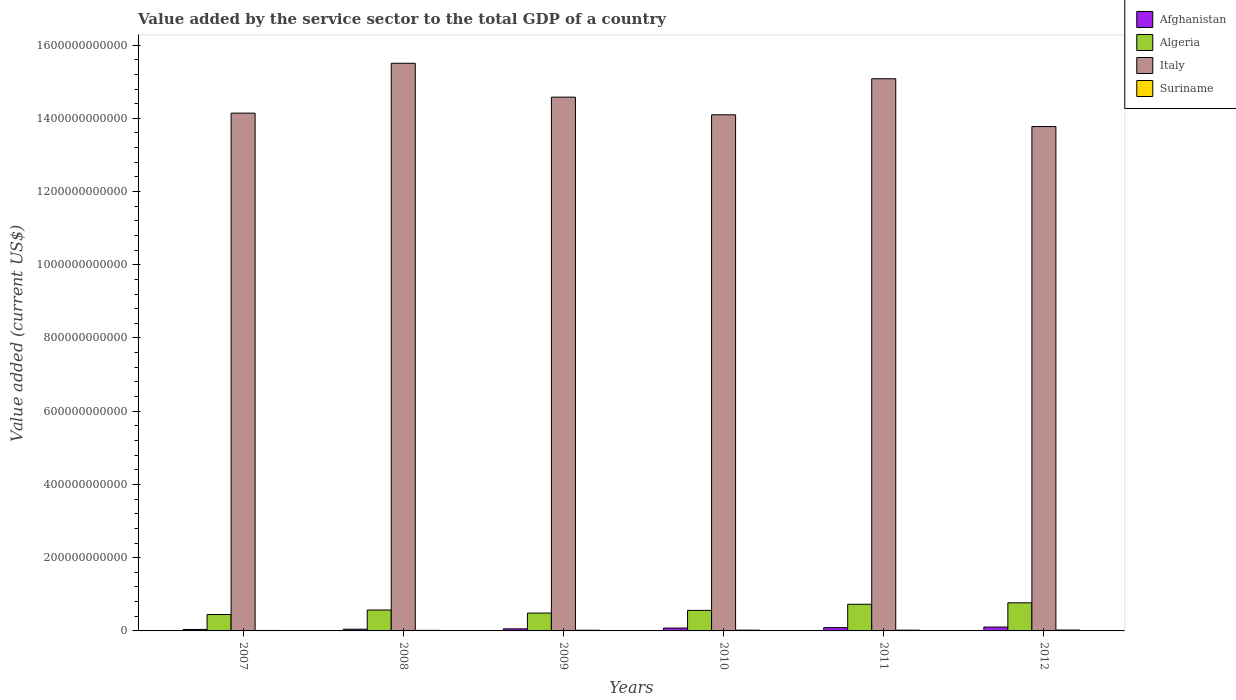How many groups of bars are there?
Your answer should be compact. 6. Are the number of bars per tick equal to the number of legend labels?
Give a very brief answer. Yes. Are the number of bars on each tick of the X-axis equal?
Keep it short and to the point. Yes. How many bars are there on the 1st tick from the left?
Keep it short and to the point. 4. In how many cases, is the number of bars for a given year not equal to the number of legend labels?
Provide a succinct answer. 0. What is the value added by the service sector to the total GDP in Suriname in 2010?
Offer a very short reply. 2.09e+09. Across all years, what is the maximum value added by the service sector to the total GDP in Suriname?
Keep it short and to the point. 2.39e+09. Across all years, what is the minimum value added by the service sector to the total GDP in Afghanistan?
Give a very brief answer. 4.03e+09. In which year was the value added by the service sector to the total GDP in Italy maximum?
Provide a succinct answer. 2008. What is the total value added by the service sector to the total GDP in Algeria in the graph?
Your answer should be compact. 3.56e+11. What is the difference between the value added by the service sector to the total GDP in Suriname in 2009 and that in 2012?
Your answer should be very brief. -5.57e+08. What is the difference between the value added by the service sector to the total GDP in Algeria in 2011 and the value added by the service sector to the total GDP in Italy in 2010?
Offer a very short reply. -1.34e+12. What is the average value added by the service sector to the total GDP in Italy per year?
Provide a short and direct response. 1.45e+12. In the year 2008, what is the difference between the value added by the service sector to the total GDP in Italy and value added by the service sector to the total GDP in Suriname?
Your response must be concise. 1.55e+12. In how many years, is the value added by the service sector to the total GDP in Italy greater than 1400000000000 US$?
Your answer should be very brief. 5. What is the ratio of the value added by the service sector to the total GDP in Algeria in 2008 to that in 2009?
Provide a succinct answer. 1.17. Is the difference between the value added by the service sector to the total GDP in Italy in 2009 and 2010 greater than the difference between the value added by the service sector to the total GDP in Suriname in 2009 and 2010?
Offer a very short reply. Yes. What is the difference between the highest and the second highest value added by the service sector to the total GDP in Suriname?
Give a very brief answer. 3.01e+08. What is the difference between the highest and the lowest value added by the service sector to the total GDP in Italy?
Provide a succinct answer. 1.73e+11. What does the 4th bar from the left in 2009 represents?
Provide a succinct answer. Suriname. What does the 3rd bar from the right in 2007 represents?
Offer a terse response. Algeria. Is it the case that in every year, the sum of the value added by the service sector to the total GDP in Suriname and value added by the service sector to the total GDP in Algeria is greater than the value added by the service sector to the total GDP in Afghanistan?
Provide a short and direct response. Yes. How many bars are there?
Make the answer very short. 24. How many years are there in the graph?
Your answer should be compact. 6. What is the difference between two consecutive major ticks on the Y-axis?
Ensure brevity in your answer.  2.00e+11. Are the values on the major ticks of Y-axis written in scientific E-notation?
Your answer should be compact. No. Does the graph contain any zero values?
Offer a very short reply. No. Does the graph contain grids?
Your answer should be compact. No. How many legend labels are there?
Offer a terse response. 4. How are the legend labels stacked?
Provide a succinct answer. Vertical. What is the title of the graph?
Ensure brevity in your answer.  Value added by the service sector to the total GDP of a country. What is the label or title of the X-axis?
Your answer should be very brief. Years. What is the label or title of the Y-axis?
Offer a terse response. Value added (current US$). What is the Value added (current US$) in Afghanistan in 2007?
Provide a succinct answer. 4.03e+09. What is the Value added (current US$) in Algeria in 2007?
Give a very brief answer. 4.48e+1. What is the Value added (current US$) of Italy in 2007?
Provide a short and direct response. 1.41e+12. What is the Value added (current US$) of Suriname in 2007?
Your response must be concise. 1.30e+09. What is the Value added (current US$) of Afghanistan in 2008?
Ensure brevity in your answer.  4.67e+09. What is the Value added (current US$) of Algeria in 2008?
Your answer should be very brief. 5.71e+1. What is the Value added (current US$) of Italy in 2008?
Give a very brief answer. 1.55e+12. What is the Value added (current US$) of Suriname in 2008?
Provide a short and direct response. 1.55e+09. What is the Value added (current US$) of Afghanistan in 2009?
Give a very brief answer. 5.69e+09. What is the Value added (current US$) in Algeria in 2009?
Your answer should be very brief. 4.88e+1. What is the Value added (current US$) of Italy in 2009?
Provide a short and direct response. 1.46e+12. What is the Value added (current US$) of Suriname in 2009?
Your answer should be compact. 1.83e+09. What is the Value added (current US$) of Afghanistan in 2010?
Make the answer very short. 7.83e+09. What is the Value added (current US$) of Algeria in 2010?
Ensure brevity in your answer.  5.61e+1. What is the Value added (current US$) in Italy in 2010?
Give a very brief answer. 1.41e+12. What is the Value added (current US$) of Suriname in 2010?
Your answer should be very brief. 2.09e+09. What is the Value added (current US$) in Afghanistan in 2011?
Your response must be concise. 8.97e+09. What is the Value added (current US$) of Algeria in 2011?
Give a very brief answer. 7.28e+1. What is the Value added (current US$) in Italy in 2011?
Keep it short and to the point. 1.51e+12. What is the Value added (current US$) of Suriname in 2011?
Provide a succinct answer. 2.06e+09. What is the Value added (current US$) in Afghanistan in 2012?
Provide a succinct answer. 1.06e+1. What is the Value added (current US$) in Algeria in 2012?
Provide a short and direct response. 7.68e+1. What is the Value added (current US$) of Italy in 2012?
Make the answer very short. 1.38e+12. What is the Value added (current US$) of Suriname in 2012?
Give a very brief answer. 2.39e+09. Across all years, what is the maximum Value added (current US$) of Afghanistan?
Keep it short and to the point. 1.06e+1. Across all years, what is the maximum Value added (current US$) of Algeria?
Make the answer very short. 7.68e+1. Across all years, what is the maximum Value added (current US$) in Italy?
Your answer should be compact. 1.55e+12. Across all years, what is the maximum Value added (current US$) of Suriname?
Your answer should be very brief. 2.39e+09. Across all years, what is the minimum Value added (current US$) of Afghanistan?
Offer a terse response. 4.03e+09. Across all years, what is the minimum Value added (current US$) in Algeria?
Provide a short and direct response. 4.48e+1. Across all years, what is the minimum Value added (current US$) in Italy?
Make the answer very short. 1.38e+12. Across all years, what is the minimum Value added (current US$) of Suriname?
Your answer should be compact. 1.30e+09. What is the total Value added (current US$) in Afghanistan in the graph?
Your answer should be compact. 4.18e+1. What is the total Value added (current US$) in Algeria in the graph?
Keep it short and to the point. 3.56e+11. What is the total Value added (current US$) in Italy in the graph?
Keep it short and to the point. 8.72e+12. What is the total Value added (current US$) of Suriname in the graph?
Offer a terse response. 1.12e+1. What is the difference between the Value added (current US$) of Afghanistan in 2007 and that in 2008?
Offer a very short reply. -6.46e+08. What is the difference between the Value added (current US$) in Algeria in 2007 and that in 2008?
Your answer should be compact. -1.22e+1. What is the difference between the Value added (current US$) in Italy in 2007 and that in 2008?
Offer a very short reply. -1.36e+11. What is the difference between the Value added (current US$) of Suriname in 2007 and that in 2008?
Your answer should be compact. -2.44e+08. What is the difference between the Value added (current US$) in Afghanistan in 2007 and that in 2009?
Provide a short and direct response. -1.66e+09. What is the difference between the Value added (current US$) of Algeria in 2007 and that in 2009?
Make the answer very short. -3.97e+09. What is the difference between the Value added (current US$) of Italy in 2007 and that in 2009?
Give a very brief answer. -4.36e+1. What is the difference between the Value added (current US$) of Suriname in 2007 and that in 2009?
Offer a very short reply. -5.31e+08. What is the difference between the Value added (current US$) of Afghanistan in 2007 and that in 2010?
Provide a short and direct response. -3.80e+09. What is the difference between the Value added (current US$) of Algeria in 2007 and that in 2010?
Offer a terse response. -1.13e+1. What is the difference between the Value added (current US$) of Italy in 2007 and that in 2010?
Your answer should be very brief. 4.55e+09. What is the difference between the Value added (current US$) of Suriname in 2007 and that in 2010?
Your answer should be very brief. -7.87e+08. What is the difference between the Value added (current US$) in Afghanistan in 2007 and that in 2011?
Keep it short and to the point. -4.95e+09. What is the difference between the Value added (current US$) in Algeria in 2007 and that in 2011?
Your response must be concise. -2.80e+1. What is the difference between the Value added (current US$) in Italy in 2007 and that in 2011?
Provide a short and direct response. -9.39e+1. What is the difference between the Value added (current US$) of Suriname in 2007 and that in 2011?
Offer a very short reply. -7.61e+08. What is the difference between the Value added (current US$) in Afghanistan in 2007 and that in 2012?
Provide a succinct answer. -6.54e+09. What is the difference between the Value added (current US$) of Algeria in 2007 and that in 2012?
Your answer should be compact. -3.19e+1. What is the difference between the Value added (current US$) in Italy in 2007 and that in 2012?
Offer a terse response. 3.67e+1. What is the difference between the Value added (current US$) of Suriname in 2007 and that in 2012?
Offer a terse response. -1.09e+09. What is the difference between the Value added (current US$) in Afghanistan in 2008 and that in 2009?
Make the answer very short. -1.02e+09. What is the difference between the Value added (current US$) of Algeria in 2008 and that in 2009?
Your answer should be compact. 8.27e+09. What is the difference between the Value added (current US$) in Italy in 2008 and that in 2009?
Provide a succinct answer. 9.26e+1. What is the difference between the Value added (current US$) in Suriname in 2008 and that in 2009?
Keep it short and to the point. -2.87e+08. What is the difference between the Value added (current US$) of Afghanistan in 2008 and that in 2010?
Provide a short and direct response. -3.16e+09. What is the difference between the Value added (current US$) of Algeria in 2008 and that in 2010?
Ensure brevity in your answer.  9.84e+08. What is the difference between the Value added (current US$) of Italy in 2008 and that in 2010?
Keep it short and to the point. 1.41e+11. What is the difference between the Value added (current US$) in Suriname in 2008 and that in 2010?
Provide a succinct answer. -5.43e+08. What is the difference between the Value added (current US$) of Afghanistan in 2008 and that in 2011?
Offer a very short reply. -4.30e+09. What is the difference between the Value added (current US$) of Algeria in 2008 and that in 2011?
Offer a terse response. -1.57e+1. What is the difference between the Value added (current US$) in Italy in 2008 and that in 2011?
Offer a terse response. 4.23e+1. What is the difference between the Value added (current US$) in Suriname in 2008 and that in 2011?
Keep it short and to the point. -5.17e+08. What is the difference between the Value added (current US$) of Afghanistan in 2008 and that in 2012?
Make the answer very short. -5.90e+09. What is the difference between the Value added (current US$) in Algeria in 2008 and that in 2012?
Provide a short and direct response. -1.97e+1. What is the difference between the Value added (current US$) of Italy in 2008 and that in 2012?
Ensure brevity in your answer.  1.73e+11. What is the difference between the Value added (current US$) in Suriname in 2008 and that in 2012?
Your answer should be very brief. -8.44e+08. What is the difference between the Value added (current US$) in Afghanistan in 2009 and that in 2010?
Give a very brief answer. -2.14e+09. What is the difference between the Value added (current US$) of Algeria in 2009 and that in 2010?
Your answer should be compact. -7.29e+09. What is the difference between the Value added (current US$) of Italy in 2009 and that in 2010?
Provide a succinct answer. 4.82e+1. What is the difference between the Value added (current US$) in Suriname in 2009 and that in 2010?
Provide a succinct answer. -2.56e+08. What is the difference between the Value added (current US$) in Afghanistan in 2009 and that in 2011?
Give a very brief answer. -3.29e+09. What is the difference between the Value added (current US$) of Algeria in 2009 and that in 2011?
Ensure brevity in your answer.  -2.40e+1. What is the difference between the Value added (current US$) in Italy in 2009 and that in 2011?
Give a very brief answer. -5.03e+1. What is the difference between the Value added (current US$) in Suriname in 2009 and that in 2011?
Offer a terse response. -2.30e+08. What is the difference between the Value added (current US$) in Afghanistan in 2009 and that in 2012?
Keep it short and to the point. -4.88e+09. What is the difference between the Value added (current US$) of Algeria in 2009 and that in 2012?
Ensure brevity in your answer.  -2.80e+1. What is the difference between the Value added (current US$) of Italy in 2009 and that in 2012?
Offer a terse response. 8.03e+1. What is the difference between the Value added (current US$) of Suriname in 2009 and that in 2012?
Offer a terse response. -5.57e+08. What is the difference between the Value added (current US$) of Afghanistan in 2010 and that in 2011?
Ensure brevity in your answer.  -1.14e+09. What is the difference between the Value added (current US$) of Algeria in 2010 and that in 2011?
Your answer should be very brief. -1.67e+1. What is the difference between the Value added (current US$) of Italy in 2010 and that in 2011?
Your response must be concise. -9.85e+1. What is the difference between the Value added (current US$) in Suriname in 2010 and that in 2011?
Make the answer very short. 2.58e+07. What is the difference between the Value added (current US$) in Afghanistan in 2010 and that in 2012?
Your answer should be compact. -2.74e+09. What is the difference between the Value added (current US$) of Algeria in 2010 and that in 2012?
Keep it short and to the point. -2.07e+1. What is the difference between the Value added (current US$) in Italy in 2010 and that in 2012?
Ensure brevity in your answer.  3.21e+1. What is the difference between the Value added (current US$) of Suriname in 2010 and that in 2012?
Your answer should be compact. -3.01e+08. What is the difference between the Value added (current US$) of Afghanistan in 2011 and that in 2012?
Your answer should be compact. -1.59e+09. What is the difference between the Value added (current US$) of Algeria in 2011 and that in 2012?
Give a very brief answer. -3.96e+09. What is the difference between the Value added (current US$) in Italy in 2011 and that in 2012?
Give a very brief answer. 1.31e+11. What is the difference between the Value added (current US$) of Suriname in 2011 and that in 2012?
Give a very brief answer. -3.27e+08. What is the difference between the Value added (current US$) in Afghanistan in 2007 and the Value added (current US$) in Algeria in 2008?
Your answer should be compact. -5.31e+1. What is the difference between the Value added (current US$) in Afghanistan in 2007 and the Value added (current US$) in Italy in 2008?
Make the answer very short. -1.55e+12. What is the difference between the Value added (current US$) of Afghanistan in 2007 and the Value added (current US$) of Suriname in 2008?
Your answer should be very brief. 2.48e+09. What is the difference between the Value added (current US$) of Algeria in 2007 and the Value added (current US$) of Italy in 2008?
Your answer should be compact. -1.51e+12. What is the difference between the Value added (current US$) in Algeria in 2007 and the Value added (current US$) in Suriname in 2008?
Your response must be concise. 4.33e+1. What is the difference between the Value added (current US$) of Italy in 2007 and the Value added (current US$) of Suriname in 2008?
Ensure brevity in your answer.  1.41e+12. What is the difference between the Value added (current US$) in Afghanistan in 2007 and the Value added (current US$) in Algeria in 2009?
Make the answer very short. -4.48e+1. What is the difference between the Value added (current US$) of Afghanistan in 2007 and the Value added (current US$) of Italy in 2009?
Keep it short and to the point. -1.45e+12. What is the difference between the Value added (current US$) of Afghanistan in 2007 and the Value added (current US$) of Suriname in 2009?
Ensure brevity in your answer.  2.19e+09. What is the difference between the Value added (current US$) of Algeria in 2007 and the Value added (current US$) of Italy in 2009?
Your answer should be very brief. -1.41e+12. What is the difference between the Value added (current US$) of Algeria in 2007 and the Value added (current US$) of Suriname in 2009?
Your answer should be compact. 4.30e+1. What is the difference between the Value added (current US$) in Italy in 2007 and the Value added (current US$) in Suriname in 2009?
Ensure brevity in your answer.  1.41e+12. What is the difference between the Value added (current US$) in Afghanistan in 2007 and the Value added (current US$) in Algeria in 2010?
Offer a terse response. -5.21e+1. What is the difference between the Value added (current US$) of Afghanistan in 2007 and the Value added (current US$) of Italy in 2010?
Keep it short and to the point. -1.41e+12. What is the difference between the Value added (current US$) of Afghanistan in 2007 and the Value added (current US$) of Suriname in 2010?
Offer a very short reply. 1.94e+09. What is the difference between the Value added (current US$) in Algeria in 2007 and the Value added (current US$) in Italy in 2010?
Provide a short and direct response. -1.36e+12. What is the difference between the Value added (current US$) of Algeria in 2007 and the Value added (current US$) of Suriname in 2010?
Provide a succinct answer. 4.28e+1. What is the difference between the Value added (current US$) in Italy in 2007 and the Value added (current US$) in Suriname in 2010?
Your answer should be compact. 1.41e+12. What is the difference between the Value added (current US$) of Afghanistan in 2007 and the Value added (current US$) of Algeria in 2011?
Provide a short and direct response. -6.88e+1. What is the difference between the Value added (current US$) in Afghanistan in 2007 and the Value added (current US$) in Italy in 2011?
Your answer should be very brief. -1.50e+12. What is the difference between the Value added (current US$) in Afghanistan in 2007 and the Value added (current US$) in Suriname in 2011?
Your answer should be compact. 1.96e+09. What is the difference between the Value added (current US$) in Algeria in 2007 and the Value added (current US$) in Italy in 2011?
Ensure brevity in your answer.  -1.46e+12. What is the difference between the Value added (current US$) of Algeria in 2007 and the Value added (current US$) of Suriname in 2011?
Offer a very short reply. 4.28e+1. What is the difference between the Value added (current US$) in Italy in 2007 and the Value added (current US$) in Suriname in 2011?
Provide a succinct answer. 1.41e+12. What is the difference between the Value added (current US$) in Afghanistan in 2007 and the Value added (current US$) in Algeria in 2012?
Offer a very short reply. -7.28e+1. What is the difference between the Value added (current US$) in Afghanistan in 2007 and the Value added (current US$) in Italy in 2012?
Provide a succinct answer. -1.37e+12. What is the difference between the Value added (current US$) of Afghanistan in 2007 and the Value added (current US$) of Suriname in 2012?
Offer a terse response. 1.64e+09. What is the difference between the Value added (current US$) in Algeria in 2007 and the Value added (current US$) in Italy in 2012?
Give a very brief answer. -1.33e+12. What is the difference between the Value added (current US$) in Algeria in 2007 and the Value added (current US$) in Suriname in 2012?
Your answer should be compact. 4.25e+1. What is the difference between the Value added (current US$) of Italy in 2007 and the Value added (current US$) of Suriname in 2012?
Ensure brevity in your answer.  1.41e+12. What is the difference between the Value added (current US$) of Afghanistan in 2008 and the Value added (current US$) of Algeria in 2009?
Your response must be concise. -4.41e+1. What is the difference between the Value added (current US$) in Afghanistan in 2008 and the Value added (current US$) in Italy in 2009?
Offer a very short reply. -1.45e+12. What is the difference between the Value added (current US$) of Afghanistan in 2008 and the Value added (current US$) of Suriname in 2009?
Keep it short and to the point. 2.84e+09. What is the difference between the Value added (current US$) of Algeria in 2008 and the Value added (current US$) of Italy in 2009?
Provide a succinct answer. -1.40e+12. What is the difference between the Value added (current US$) of Algeria in 2008 and the Value added (current US$) of Suriname in 2009?
Your answer should be very brief. 5.53e+1. What is the difference between the Value added (current US$) in Italy in 2008 and the Value added (current US$) in Suriname in 2009?
Your answer should be very brief. 1.55e+12. What is the difference between the Value added (current US$) in Afghanistan in 2008 and the Value added (current US$) in Algeria in 2010?
Ensure brevity in your answer.  -5.14e+1. What is the difference between the Value added (current US$) in Afghanistan in 2008 and the Value added (current US$) in Italy in 2010?
Offer a very short reply. -1.40e+12. What is the difference between the Value added (current US$) of Afghanistan in 2008 and the Value added (current US$) of Suriname in 2010?
Provide a short and direct response. 2.58e+09. What is the difference between the Value added (current US$) of Algeria in 2008 and the Value added (current US$) of Italy in 2010?
Offer a very short reply. -1.35e+12. What is the difference between the Value added (current US$) of Algeria in 2008 and the Value added (current US$) of Suriname in 2010?
Your answer should be very brief. 5.50e+1. What is the difference between the Value added (current US$) of Italy in 2008 and the Value added (current US$) of Suriname in 2010?
Your answer should be compact. 1.55e+12. What is the difference between the Value added (current US$) in Afghanistan in 2008 and the Value added (current US$) in Algeria in 2011?
Provide a succinct answer. -6.81e+1. What is the difference between the Value added (current US$) in Afghanistan in 2008 and the Value added (current US$) in Italy in 2011?
Make the answer very short. -1.50e+12. What is the difference between the Value added (current US$) in Afghanistan in 2008 and the Value added (current US$) in Suriname in 2011?
Provide a succinct answer. 2.61e+09. What is the difference between the Value added (current US$) in Algeria in 2008 and the Value added (current US$) in Italy in 2011?
Make the answer very short. -1.45e+12. What is the difference between the Value added (current US$) of Algeria in 2008 and the Value added (current US$) of Suriname in 2011?
Provide a succinct answer. 5.50e+1. What is the difference between the Value added (current US$) in Italy in 2008 and the Value added (current US$) in Suriname in 2011?
Make the answer very short. 1.55e+12. What is the difference between the Value added (current US$) of Afghanistan in 2008 and the Value added (current US$) of Algeria in 2012?
Your answer should be compact. -7.21e+1. What is the difference between the Value added (current US$) of Afghanistan in 2008 and the Value added (current US$) of Italy in 2012?
Keep it short and to the point. -1.37e+12. What is the difference between the Value added (current US$) of Afghanistan in 2008 and the Value added (current US$) of Suriname in 2012?
Your answer should be compact. 2.28e+09. What is the difference between the Value added (current US$) of Algeria in 2008 and the Value added (current US$) of Italy in 2012?
Your response must be concise. -1.32e+12. What is the difference between the Value added (current US$) in Algeria in 2008 and the Value added (current US$) in Suriname in 2012?
Make the answer very short. 5.47e+1. What is the difference between the Value added (current US$) in Italy in 2008 and the Value added (current US$) in Suriname in 2012?
Your answer should be very brief. 1.55e+12. What is the difference between the Value added (current US$) of Afghanistan in 2009 and the Value added (current US$) of Algeria in 2010?
Provide a succinct answer. -5.04e+1. What is the difference between the Value added (current US$) of Afghanistan in 2009 and the Value added (current US$) of Italy in 2010?
Keep it short and to the point. -1.40e+12. What is the difference between the Value added (current US$) in Afghanistan in 2009 and the Value added (current US$) in Suriname in 2010?
Provide a succinct answer. 3.60e+09. What is the difference between the Value added (current US$) in Algeria in 2009 and the Value added (current US$) in Italy in 2010?
Keep it short and to the point. -1.36e+12. What is the difference between the Value added (current US$) in Algeria in 2009 and the Value added (current US$) in Suriname in 2010?
Offer a terse response. 4.67e+1. What is the difference between the Value added (current US$) in Italy in 2009 and the Value added (current US$) in Suriname in 2010?
Offer a terse response. 1.46e+12. What is the difference between the Value added (current US$) in Afghanistan in 2009 and the Value added (current US$) in Algeria in 2011?
Give a very brief answer. -6.71e+1. What is the difference between the Value added (current US$) of Afghanistan in 2009 and the Value added (current US$) of Italy in 2011?
Keep it short and to the point. -1.50e+12. What is the difference between the Value added (current US$) in Afghanistan in 2009 and the Value added (current US$) in Suriname in 2011?
Make the answer very short. 3.62e+09. What is the difference between the Value added (current US$) in Algeria in 2009 and the Value added (current US$) in Italy in 2011?
Offer a terse response. -1.46e+12. What is the difference between the Value added (current US$) of Algeria in 2009 and the Value added (current US$) of Suriname in 2011?
Your answer should be very brief. 4.68e+1. What is the difference between the Value added (current US$) in Italy in 2009 and the Value added (current US$) in Suriname in 2011?
Ensure brevity in your answer.  1.46e+12. What is the difference between the Value added (current US$) of Afghanistan in 2009 and the Value added (current US$) of Algeria in 2012?
Give a very brief answer. -7.11e+1. What is the difference between the Value added (current US$) of Afghanistan in 2009 and the Value added (current US$) of Italy in 2012?
Keep it short and to the point. -1.37e+12. What is the difference between the Value added (current US$) of Afghanistan in 2009 and the Value added (current US$) of Suriname in 2012?
Your answer should be compact. 3.30e+09. What is the difference between the Value added (current US$) of Algeria in 2009 and the Value added (current US$) of Italy in 2012?
Ensure brevity in your answer.  -1.33e+12. What is the difference between the Value added (current US$) of Algeria in 2009 and the Value added (current US$) of Suriname in 2012?
Offer a terse response. 4.64e+1. What is the difference between the Value added (current US$) of Italy in 2009 and the Value added (current US$) of Suriname in 2012?
Offer a terse response. 1.46e+12. What is the difference between the Value added (current US$) of Afghanistan in 2010 and the Value added (current US$) of Algeria in 2011?
Ensure brevity in your answer.  -6.50e+1. What is the difference between the Value added (current US$) in Afghanistan in 2010 and the Value added (current US$) in Italy in 2011?
Give a very brief answer. -1.50e+12. What is the difference between the Value added (current US$) in Afghanistan in 2010 and the Value added (current US$) in Suriname in 2011?
Provide a succinct answer. 5.77e+09. What is the difference between the Value added (current US$) of Algeria in 2010 and the Value added (current US$) of Italy in 2011?
Give a very brief answer. -1.45e+12. What is the difference between the Value added (current US$) in Algeria in 2010 and the Value added (current US$) in Suriname in 2011?
Your response must be concise. 5.40e+1. What is the difference between the Value added (current US$) in Italy in 2010 and the Value added (current US$) in Suriname in 2011?
Your answer should be compact. 1.41e+12. What is the difference between the Value added (current US$) of Afghanistan in 2010 and the Value added (current US$) of Algeria in 2012?
Your answer should be very brief. -6.90e+1. What is the difference between the Value added (current US$) in Afghanistan in 2010 and the Value added (current US$) in Italy in 2012?
Keep it short and to the point. -1.37e+12. What is the difference between the Value added (current US$) in Afghanistan in 2010 and the Value added (current US$) in Suriname in 2012?
Your answer should be compact. 5.44e+09. What is the difference between the Value added (current US$) in Algeria in 2010 and the Value added (current US$) in Italy in 2012?
Provide a succinct answer. -1.32e+12. What is the difference between the Value added (current US$) of Algeria in 2010 and the Value added (current US$) of Suriname in 2012?
Your response must be concise. 5.37e+1. What is the difference between the Value added (current US$) of Italy in 2010 and the Value added (current US$) of Suriname in 2012?
Make the answer very short. 1.41e+12. What is the difference between the Value added (current US$) of Afghanistan in 2011 and the Value added (current US$) of Algeria in 2012?
Your answer should be compact. -6.78e+1. What is the difference between the Value added (current US$) in Afghanistan in 2011 and the Value added (current US$) in Italy in 2012?
Provide a succinct answer. -1.37e+12. What is the difference between the Value added (current US$) in Afghanistan in 2011 and the Value added (current US$) in Suriname in 2012?
Offer a terse response. 6.58e+09. What is the difference between the Value added (current US$) in Algeria in 2011 and the Value added (current US$) in Italy in 2012?
Ensure brevity in your answer.  -1.30e+12. What is the difference between the Value added (current US$) of Algeria in 2011 and the Value added (current US$) of Suriname in 2012?
Ensure brevity in your answer.  7.04e+1. What is the difference between the Value added (current US$) of Italy in 2011 and the Value added (current US$) of Suriname in 2012?
Keep it short and to the point. 1.51e+12. What is the average Value added (current US$) of Afghanistan per year?
Provide a succinct answer. 6.96e+09. What is the average Value added (current US$) of Algeria per year?
Your response must be concise. 5.94e+1. What is the average Value added (current US$) in Italy per year?
Your answer should be very brief. 1.45e+12. What is the average Value added (current US$) of Suriname per year?
Offer a terse response. 1.87e+09. In the year 2007, what is the difference between the Value added (current US$) in Afghanistan and Value added (current US$) in Algeria?
Make the answer very short. -4.08e+1. In the year 2007, what is the difference between the Value added (current US$) of Afghanistan and Value added (current US$) of Italy?
Provide a succinct answer. -1.41e+12. In the year 2007, what is the difference between the Value added (current US$) of Afghanistan and Value added (current US$) of Suriname?
Provide a succinct answer. 2.72e+09. In the year 2007, what is the difference between the Value added (current US$) in Algeria and Value added (current US$) in Italy?
Your response must be concise. -1.37e+12. In the year 2007, what is the difference between the Value added (current US$) in Algeria and Value added (current US$) in Suriname?
Your response must be concise. 4.35e+1. In the year 2007, what is the difference between the Value added (current US$) in Italy and Value added (current US$) in Suriname?
Give a very brief answer. 1.41e+12. In the year 2008, what is the difference between the Value added (current US$) in Afghanistan and Value added (current US$) in Algeria?
Your answer should be compact. -5.24e+1. In the year 2008, what is the difference between the Value added (current US$) of Afghanistan and Value added (current US$) of Italy?
Ensure brevity in your answer.  -1.55e+12. In the year 2008, what is the difference between the Value added (current US$) in Afghanistan and Value added (current US$) in Suriname?
Give a very brief answer. 3.12e+09. In the year 2008, what is the difference between the Value added (current US$) in Algeria and Value added (current US$) in Italy?
Your answer should be compact. -1.49e+12. In the year 2008, what is the difference between the Value added (current US$) of Algeria and Value added (current US$) of Suriname?
Offer a terse response. 5.55e+1. In the year 2008, what is the difference between the Value added (current US$) in Italy and Value added (current US$) in Suriname?
Your response must be concise. 1.55e+12. In the year 2009, what is the difference between the Value added (current US$) of Afghanistan and Value added (current US$) of Algeria?
Your answer should be compact. -4.31e+1. In the year 2009, what is the difference between the Value added (current US$) of Afghanistan and Value added (current US$) of Italy?
Provide a succinct answer. -1.45e+12. In the year 2009, what is the difference between the Value added (current US$) in Afghanistan and Value added (current US$) in Suriname?
Offer a terse response. 3.85e+09. In the year 2009, what is the difference between the Value added (current US$) in Algeria and Value added (current US$) in Italy?
Your answer should be compact. -1.41e+12. In the year 2009, what is the difference between the Value added (current US$) in Algeria and Value added (current US$) in Suriname?
Give a very brief answer. 4.70e+1. In the year 2009, what is the difference between the Value added (current US$) of Italy and Value added (current US$) of Suriname?
Keep it short and to the point. 1.46e+12. In the year 2010, what is the difference between the Value added (current US$) in Afghanistan and Value added (current US$) in Algeria?
Your answer should be very brief. -4.83e+1. In the year 2010, what is the difference between the Value added (current US$) in Afghanistan and Value added (current US$) in Italy?
Offer a terse response. -1.40e+12. In the year 2010, what is the difference between the Value added (current US$) in Afghanistan and Value added (current US$) in Suriname?
Offer a very short reply. 5.74e+09. In the year 2010, what is the difference between the Value added (current US$) in Algeria and Value added (current US$) in Italy?
Ensure brevity in your answer.  -1.35e+12. In the year 2010, what is the difference between the Value added (current US$) of Algeria and Value added (current US$) of Suriname?
Make the answer very short. 5.40e+1. In the year 2010, what is the difference between the Value added (current US$) in Italy and Value added (current US$) in Suriname?
Offer a terse response. 1.41e+12. In the year 2011, what is the difference between the Value added (current US$) in Afghanistan and Value added (current US$) in Algeria?
Give a very brief answer. -6.38e+1. In the year 2011, what is the difference between the Value added (current US$) of Afghanistan and Value added (current US$) of Italy?
Your answer should be compact. -1.50e+12. In the year 2011, what is the difference between the Value added (current US$) of Afghanistan and Value added (current US$) of Suriname?
Give a very brief answer. 6.91e+09. In the year 2011, what is the difference between the Value added (current US$) of Algeria and Value added (current US$) of Italy?
Offer a terse response. -1.44e+12. In the year 2011, what is the difference between the Value added (current US$) in Algeria and Value added (current US$) in Suriname?
Give a very brief answer. 7.08e+1. In the year 2011, what is the difference between the Value added (current US$) of Italy and Value added (current US$) of Suriname?
Provide a short and direct response. 1.51e+12. In the year 2012, what is the difference between the Value added (current US$) of Afghanistan and Value added (current US$) of Algeria?
Provide a short and direct response. -6.62e+1. In the year 2012, what is the difference between the Value added (current US$) of Afghanistan and Value added (current US$) of Italy?
Provide a short and direct response. -1.37e+12. In the year 2012, what is the difference between the Value added (current US$) of Afghanistan and Value added (current US$) of Suriname?
Your response must be concise. 8.18e+09. In the year 2012, what is the difference between the Value added (current US$) of Algeria and Value added (current US$) of Italy?
Give a very brief answer. -1.30e+12. In the year 2012, what is the difference between the Value added (current US$) of Algeria and Value added (current US$) of Suriname?
Provide a succinct answer. 7.44e+1. In the year 2012, what is the difference between the Value added (current US$) of Italy and Value added (current US$) of Suriname?
Give a very brief answer. 1.38e+12. What is the ratio of the Value added (current US$) of Afghanistan in 2007 to that in 2008?
Your answer should be very brief. 0.86. What is the ratio of the Value added (current US$) in Algeria in 2007 to that in 2008?
Your answer should be compact. 0.79. What is the ratio of the Value added (current US$) of Italy in 2007 to that in 2008?
Keep it short and to the point. 0.91. What is the ratio of the Value added (current US$) in Suriname in 2007 to that in 2008?
Keep it short and to the point. 0.84. What is the ratio of the Value added (current US$) of Afghanistan in 2007 to that in 2009?
Keep it short and to the point. 0.71. What is the ratio of the Value added (current US$) in Algeria in 2007 to that in 2009?
Give a very brief answer. 0.92. What is the ratio of the Value added (current US$) of Italy in 2007 to that in 2009?
Make the answer very short. 0.97. What is the ratio of the Value added (current US$) in Suriname in 2007 to that in 2009?
Offer a very short reply. 0.71. What is the ratio of the Value added (current US$) in Afghanistan in 2007 to that in 2010?
Provide a short and direct response. 0.51. What is the ratio of the Value added (current US$) in Algeria in 2007 to that in 2010?
Give a very brief answer. 0.8. What is the ratio of the Value added (current US$) in Suriname in 2007 to that in 2010?
Your answer should be compact. 0.62. What is the ratio of the Value added (current US$) of Afghanistan in 2007 to that in 2011?
Your answer should be compact. 0.45. What is the ratio of the Value added (current US$) of Algeria in 2007 to that in 2011?
Ensure brevity in your answer.  0.62. What is the ratio of the Value added (current US$) in Italy in 2007 to that in 2011?
Your response must be concise. 0.94. What is the ratio of the Value added (current US$) of Suriname in 2007 to that in 2011?
Your response must be concise. 0.63. What is the ratio of the Value added (current US$) of Afghanistan in 2007 to that in 2012?
Offer a very short reply. 0.38. What is the ratio of the Value added (current US$) of Algeria in 2007 to that in 2012?
Offer a very short reply. 0.58. What is the ratio of the Value added (current US$) of Italy in 2007 to that in 2012?
Offer a terse response. 1.03. What is the ratio of the Value added (current US$) of Suriname in 2007 to that in 2012?
Provide a succinct answer. 0.55. What is the ratio of the Value added (current US$) of Afghanistan in 2008 to that in 2009?
Make the answer very short. 0.82. What is the ratio of the Value added (current US$) of Algeria in 2008 to that in 2009?
Provide a short and direct response. 1.17. What is the ratio of the Value added (current US$) in Italy in 2008 to that in 2009?
Ensure brevity in your answer.  1.06. What is the ratio of the Value added (current US$) in Suriname in 2008 to that in 2009?
Provide a short and direct response. 0.84. What is the ratio of the Value added (current US$) in Afghanistan in 2008 to that in 2010?
Provide a short and direct response. 0.6. What is the ratio of the Value added (current US$) of Algeria in 2008 to that in 2010?
Keep it short and to the point. 1.02. What is the ratio of the Value added (current US$) in Italy in 2008 to that in 2010?
Offer a very short reply. 1.1. What is the ratio of the Value added (current US$) in Suriname in 2008 to that in 2010?
Give a very brief answer. 0.74. What is the ratio of the Value added (current US$) of Afghanistan in 2008 to that in 2011?
Offer a very short reply. 0.52. What is the ratio of the Value added (current US$) of Algeria in 2008 to that in 2011?
Your answer should be very brief. 0.78. What is the ratio of the Value added (current US$) in Italy in 2008 to that in 2011?
Offer a very short reply. 1.03. What is the ratio of the Value added (current US$) of Suriname in 2008 to that in 2011?
Offer a very short reply. 0.75. What is the ratio of the Value added (current US$) of Afghanistan in 2008 to that in 2012?
Give a very brief answer. 0.44. What is the ratio of the Value added (current US$) in Algeria in 2008 to that in 2012?
Your response must be concise. 0.74. What is the ratio of the Value added (current US$) of Italy in 2008 to that in 2012?
Keep it short and to the point. 1.13. What is the ratio of the Value added (current US$) in Suriname in 2008 to that in 2012?
Provide a short and direct response. 0.65. What is the ratio of the Value added (current US$) of Afghanistan in 2009 to that in 2010?
Your answer should be compact. 0.73. What is the ratio of the Value added (current US$) of Algeria in 2009 to that in 2010?
Keep it short and to the point. 0.87. What is the ratio of the Value added (current US$) of Italy in 2009 to that in 2010?
Your answer should be compact. 1.03. What is the ratio of the Value added (current US$) in Suriname in 2009 to that in 2010?
Offer a terse response. 0.88. What is the ratio of the Value added (current US$) of Afghanistan in 2009 to that in 2011?
Offer a very short reply. 0.63. What is the ratio of the Value added (current US$) in Algeria in 2009 to that in 2011?
Give a very brief answer. 0.67. What is the ratio of the Value added (current US$) in Italy in 2009 to that in 2011?
Ensure brevity in your answer.  0.97. What is the ratio of the Value added (current US$) of Suriname in 2009 to that in 2011?
Offer a terse response. 0.89. What is the ratio of the Value added (current US$) of Afghanistan in 2009 to that in 2012?
Your answer should be compact. 0.54. What is the ratio of the Value added (current US$) of Algeria in 2009 to that in 2012?
Your answer should be very brief. 0.64. What is the ratio of the Value added (current US$) of Italy in 2009 to that in 2012?
Ensure brevity in your answer.  1.06. What is the ratio of the Value added (current US$) in Suriname in 2009 to that in 2012?
Ensure brevity in your answer.  0.77. What is the ratio of the Value added (current US$) in Afghanistan in 2010 to that in 2011?
Your answer should be compact. 0.87. What is the ratio of the Value added (current US$) in Algeria in 2010 to that in 2011?
Your answer should be very brief. 0.77. What is the ratio of the Value added (current US$) of Italy in 2010 to that in 2011?
Offer a very short reply. 0.93. What is the ratio of the Value added (current US$) of Suriname in 2010 to that in 2011?
Provide a succinct answer. 1.01. What is the ratio of the Value added (current US$) in Afghanistan in 2010 to that in 2012?
Give a very brief answer. 0.74. What is the ratio of the Value added (current US$) in Algeria in 2010 to that in 2012?
Ensure brevity in your answer.  0.73. What is the ratio of the Value added (current US$) of Italy in 2010 to that in 2012?
Provide a succinct answer. 1.02. What is the ratio of the Value added (current US$) in Suriname in 2010 to that in 2012?
Provide a succinct answer. 0.87. What is the ratio of the Value added (current US$) in Afghanistan in 2011 to that in 2012?
Make the answer very short. 0.85. What is the ratio of the Value added (current US$) of Algeria in 2011 to that in 2012?
Your response must be concise. 0.95. What is the ratio of the Value added (current US$) in Italy in 2011 to that in 2012?
Make the answer very short. 1.09. What is the ratio of the Value added (current US$) of Suriname in 2011 to that in 2012?
Your answer should be compact. 0.86. What is the difference between the highest and the second highest Value added (current US$) of Afghanistan?
Your answer should be very brief. 1.59e+09. What is the difference between the highest and the second highest Value added (current US$) of Algeria?
Provide a short and direct response. 3.96e+09. What is the difference between the highest and the second highest Value added (current US$) in Italy?
Ensure brevity in your answer.  4.23e+1. What is the difference between the highest and the second highest Value added (current US$) of Suriname?
Provide a succinct answer. 3.01e+08. What is the difference between the highest and the lowest Value added (current US$) in Afghanistan?
Offer a very short reply. 6.54e+09. What is the difference between the highest and the lowest Value added (current US$) in Algeria?
Your response must be concise. 3.19e+1. What is the difference between the highest and the lowest Value added (current US$) in Italy?
Offer a very short reply. 1.73e+11. What is the difference between the highest and the lowest Value added (current US$) of Suriname?
Give a very brief answer. 1.09e+09. 